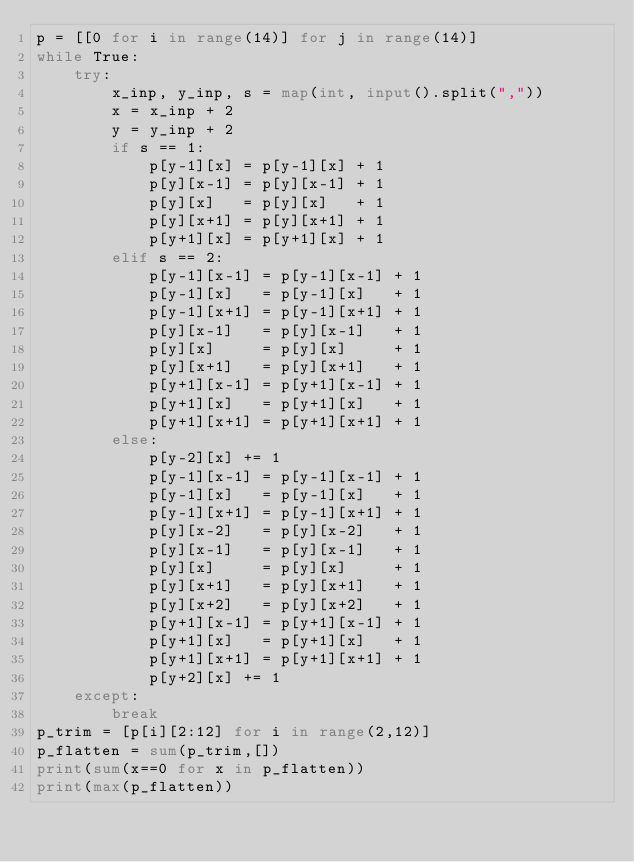Convert code to text. <code><loc_0><loc_0><loc_500><loc_500><_Python_>p = [[0 for i in range(14)] for j in range(14)]
while True:
    try:
        x_inp, y_inp, s = map(int, input().split(","))
        x = x_inp + 2
        y = y_inp + 2
        if s == 1:
            p[y-1][x] = p[y-1][x] + 1
            p[y][x-1] = p[y][x-1] + 1
            p[y][x]   = p[y][x]   + 1
            p[y][x+1] = p[y][x+1] + 1
            p[y+1][x] = p[y+1][x] + 1
        elif s == 2:
            p[y-1][x-1] = p[y-1][x-1] + 1
            p[y-1][x]   = p[y-1][x]   + 1
            p[y-1][x+1] = p[y-1][x+1] + 1
            p[y][x-1]   = p[y][x-1]   + 1
            p[y][x]     = p[y][x]     + 1
            p[y][x+1]   = p[y][x+1]   + 1
            p[y+1][x-1] = p[y+1][x-1] + 1
            p[y+1][x]   = p[y+1][x]   + 1
            p[y+1][x+1] = p[y+1][x+1] + 1
        else:
            p[y-2][x] += 1
            p[y-1][x-1] = p[y-1][x-1] + 1
            p[y-1][x]   = p[y-1][x]   + 1
            p[y-1][x+1] = p[y-1][x+1] + 1
            p[y][x-2]   = p[y][x-2]   + 1
            p[y][x-1]   = p[y][x-1]   + 1
            p[y][x]     = p[y][x]     + 1
            p[y][x+1]   = p[y][x+1]   + 1
            p[y][x+2]   = p[y][x+2]   + 1
            p[y+1][x-1] = p[y+1][x-1] + 1
            p[y+1][x]   = p[y+1][x]   + 1
            p[y+1][x+1] = p[y+1][x+1] + 1
            p[y+2][x] += 1
    except:
        break
p_trim = [p[i][2:12] for i in range(2,12)]
p_flatten = sum(p_trim,[])
print(sum(x==0 for x in p_flatten))
print(max(p_flatten))

</code> 